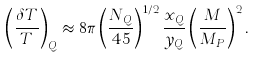<formula> <loc_0><loc_0><loc_500><loc_500>\left ( \frac { \delta T } { T } \right ) _ { Q } \approx 8 \pi \left ( \frac { N _ { Q } } { 4 5 } \right ) ^ { 1 / 2 } \frac { x _ { Q } } { y _ { Q } } \left ( \frac { M } { M _ { P } } \right ) ^ { 2 } .</formula> 